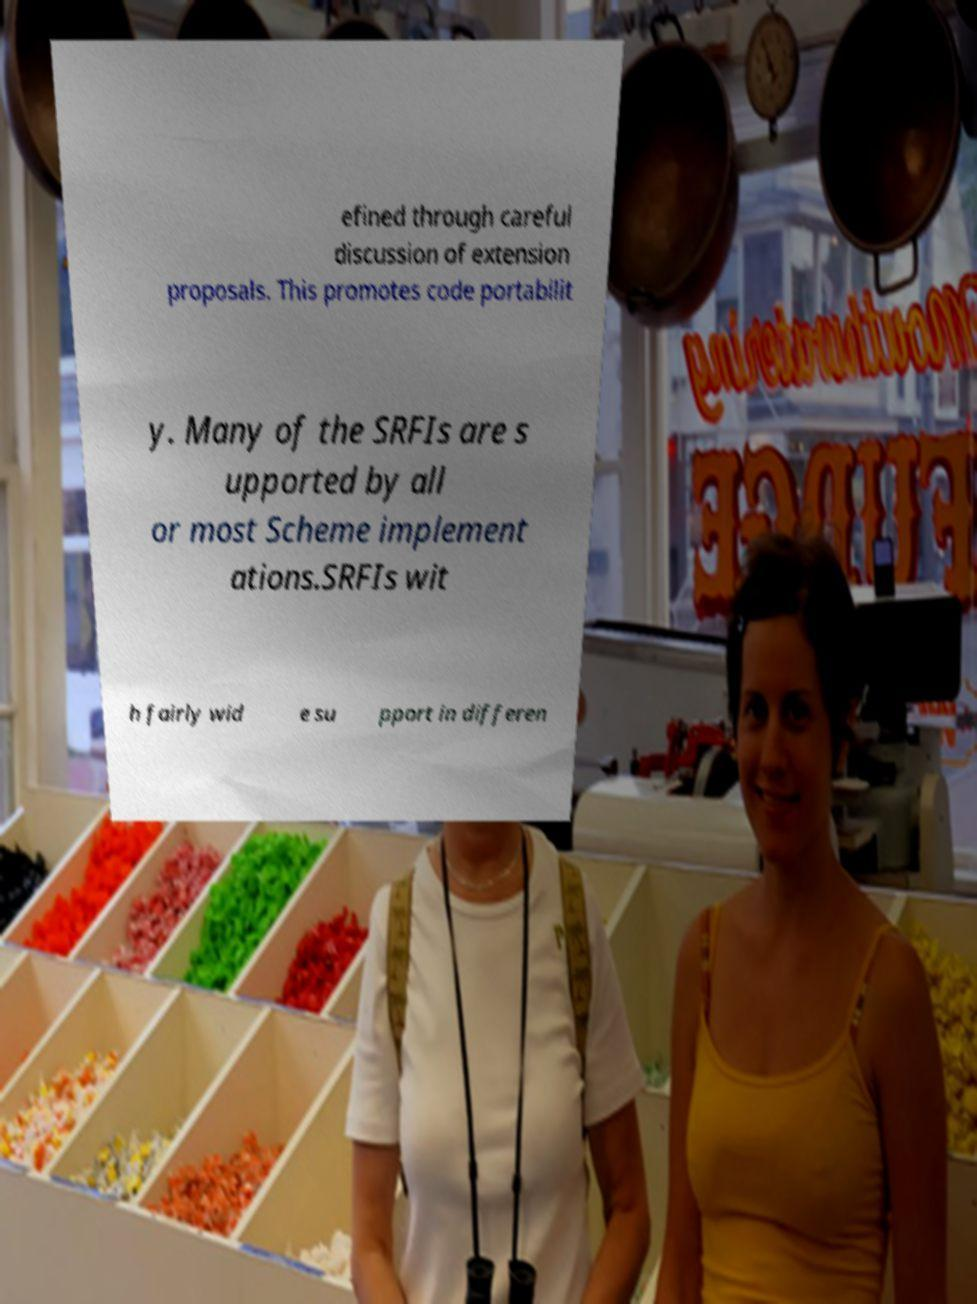Please read and relay the text visible in this image. What does it say? efined through careful discussion of extension proposals. This promotes code portabilit y. Many of the SRFIs are s upported by all or most Scheme implement ations.SRFIs wit h fairly wid e su pport in differen 